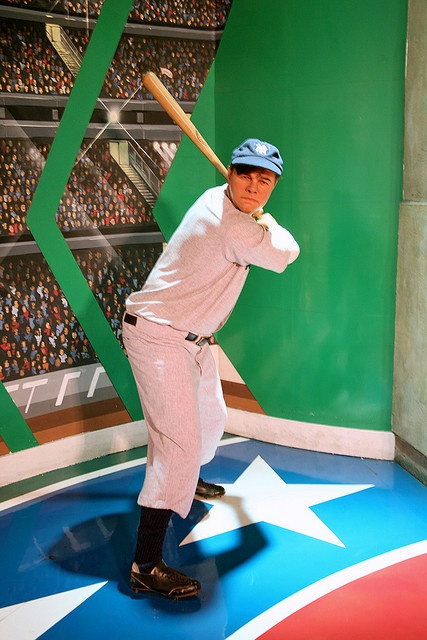Describe the objects in this image and their specific colors. I can see people in black, lightpink, lightgray, and darkgray tones and baseball bat in black, tan, red, and orange tones in this image. 